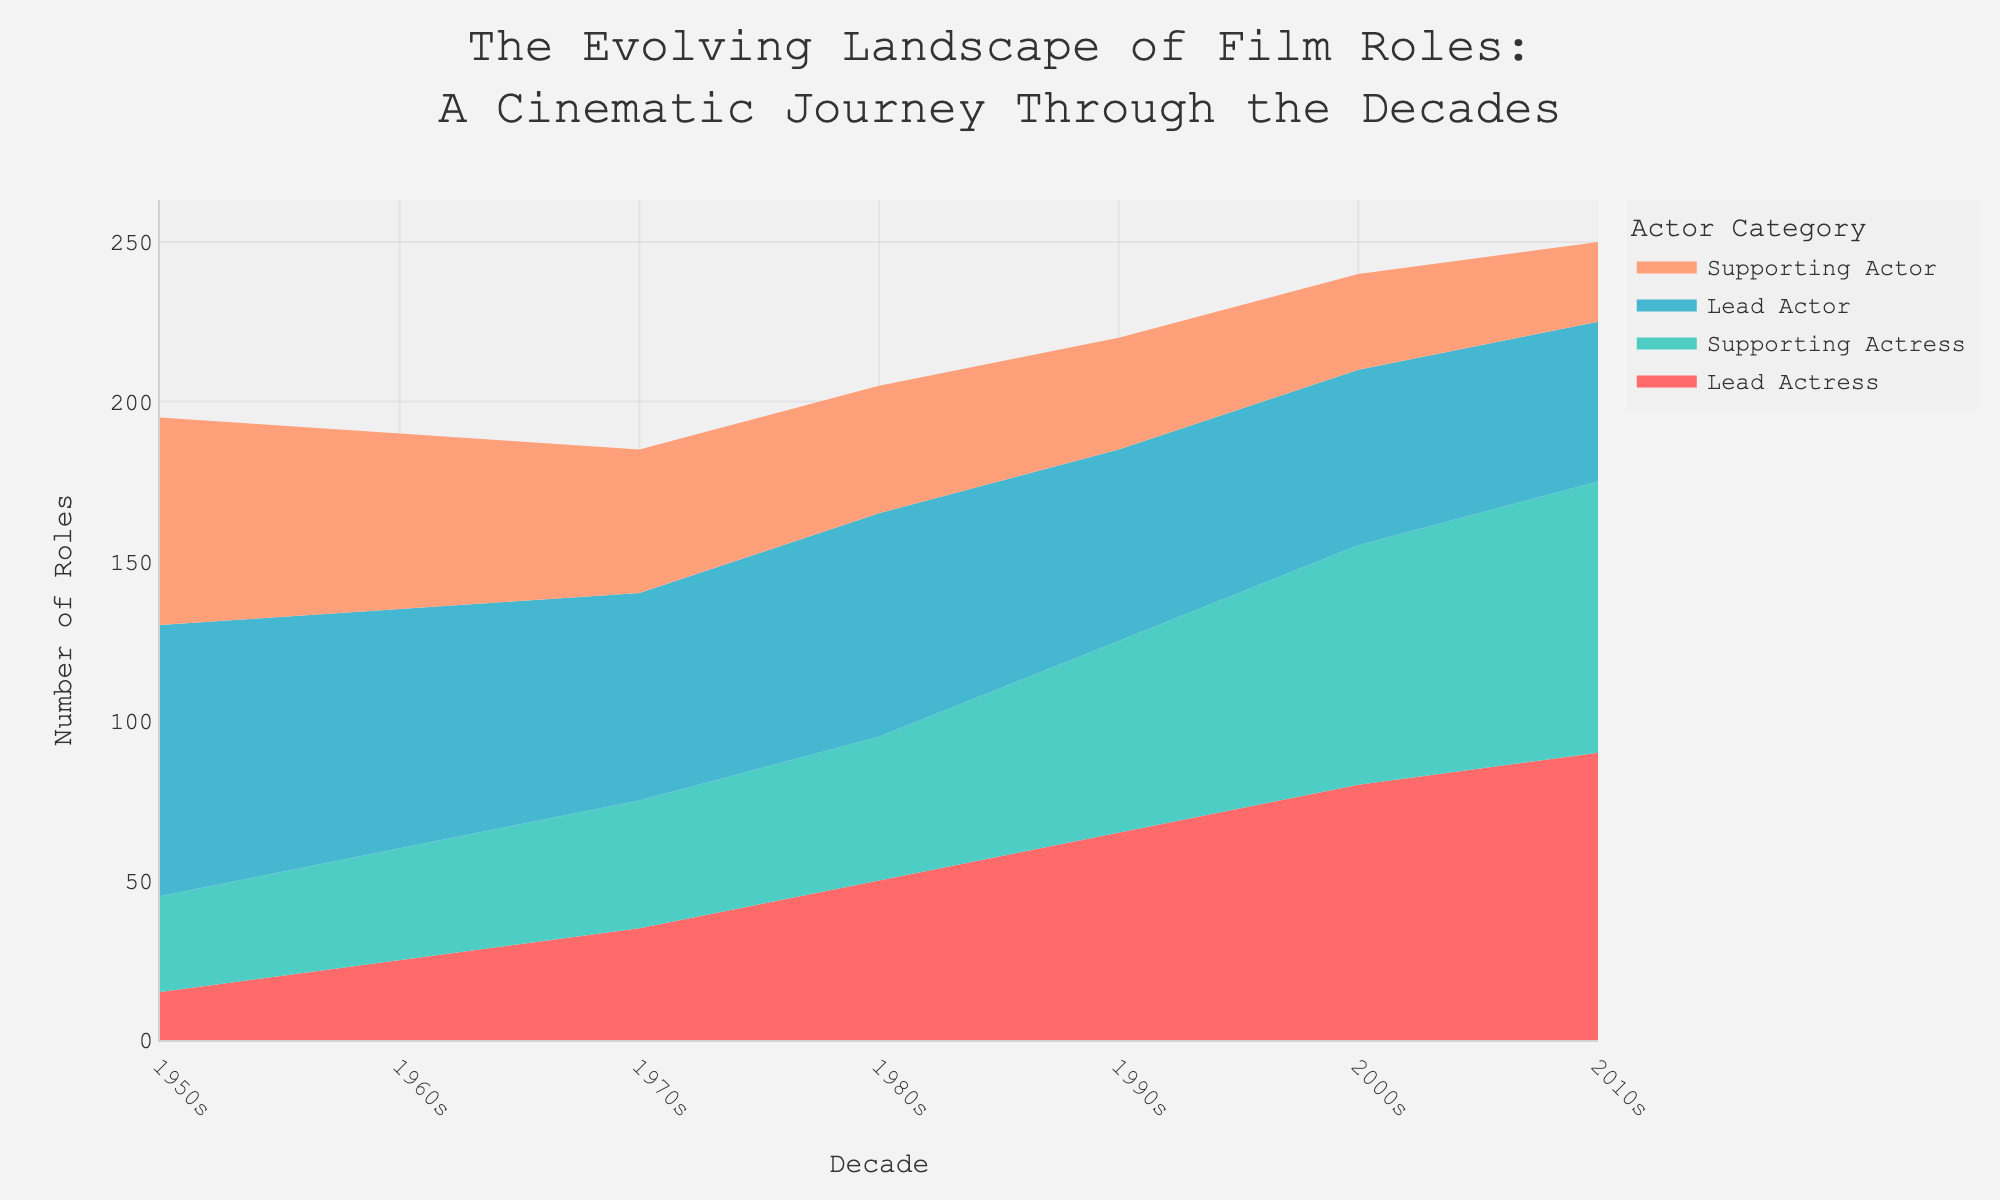what is the total number of lead actress roles in the 2010s? To find the total number of lead actress roles in the 2010s, look at the value for "Lead Actress" in the 2010s section of the chart. It shows 90.
Answer: 90 Which decade saw the highest number of female lead roles? Compare the number of lead actress roles across all decades. The 2010s have the highest value with 90 roles.
Answer: 2010s What is the difference between the number of lead and supporting actress roles in the 2000s? To calculate the difference, subtract the number of supporting actress roles in the 2000s from the lead actress roles in the same decade. That's 80 - 75.
Answer: 5 How did the number of lead actress roles change from the 1950s to the 2010s? Analyze the values for lead actress roles in both the 1950s and the 2010s. In the 1950s there were 15 roles, and in the 2010s there were 90. The increase is 90 - 15.
Answer: Increased by 75 Compare the number of supporting actress roles in the 1970s to the 1990s? Look at the number of supporting actress roles for both decades. In the 1970s, there were 40 roles, and in the 1990s, there were 60.
Answer: The 1990s had 20 more roles How has female representation in lead roles (lead actress) changed over each decade? Examine the trend of the number of lead actress roles from the 1950s onward. The figures show an increasing trend: 1950s: 15, 1960s: 25, 1970s: 35, 1980s: 50, 1990s: 65, 2000s: 80, 2010s: 90.
Answer: Increased over time What is the ratio of lead roles (actor vs actress) in the decade of the 1980s? Calculate the ratio of lead actor to lead actress roles in the 1980s: 70 (lead actors) to 50 (lead actresses). Simplify if necessary.
Answer: 7:5 How many roles were there in total for actresses (both lead and supporting) in the 2000s? Add the number of lead and supporting actress roles in the 2000s: 80 (lead) + 75 (supporting) = 155.
Answer: 155 Which decade experienced the sharpest increase in the number of lead actress roles compared to the previous decade? Calculate the difference in lead actress roles from decade to decade and identify the maximum increase: the 1980s (50 roles) increased by 15 from the 1970s (35 roles). The highest jump is between the 1970s to the 1980s: 35 to 50.
Answer: 1980s What is the combined number of lead and supporting roles for each decade for actresses in the 1990s? Add the number of lead and supporting actress roles in the 1990s: 65 (lead) + 60 (supporting) = 125.
Answer: 125 